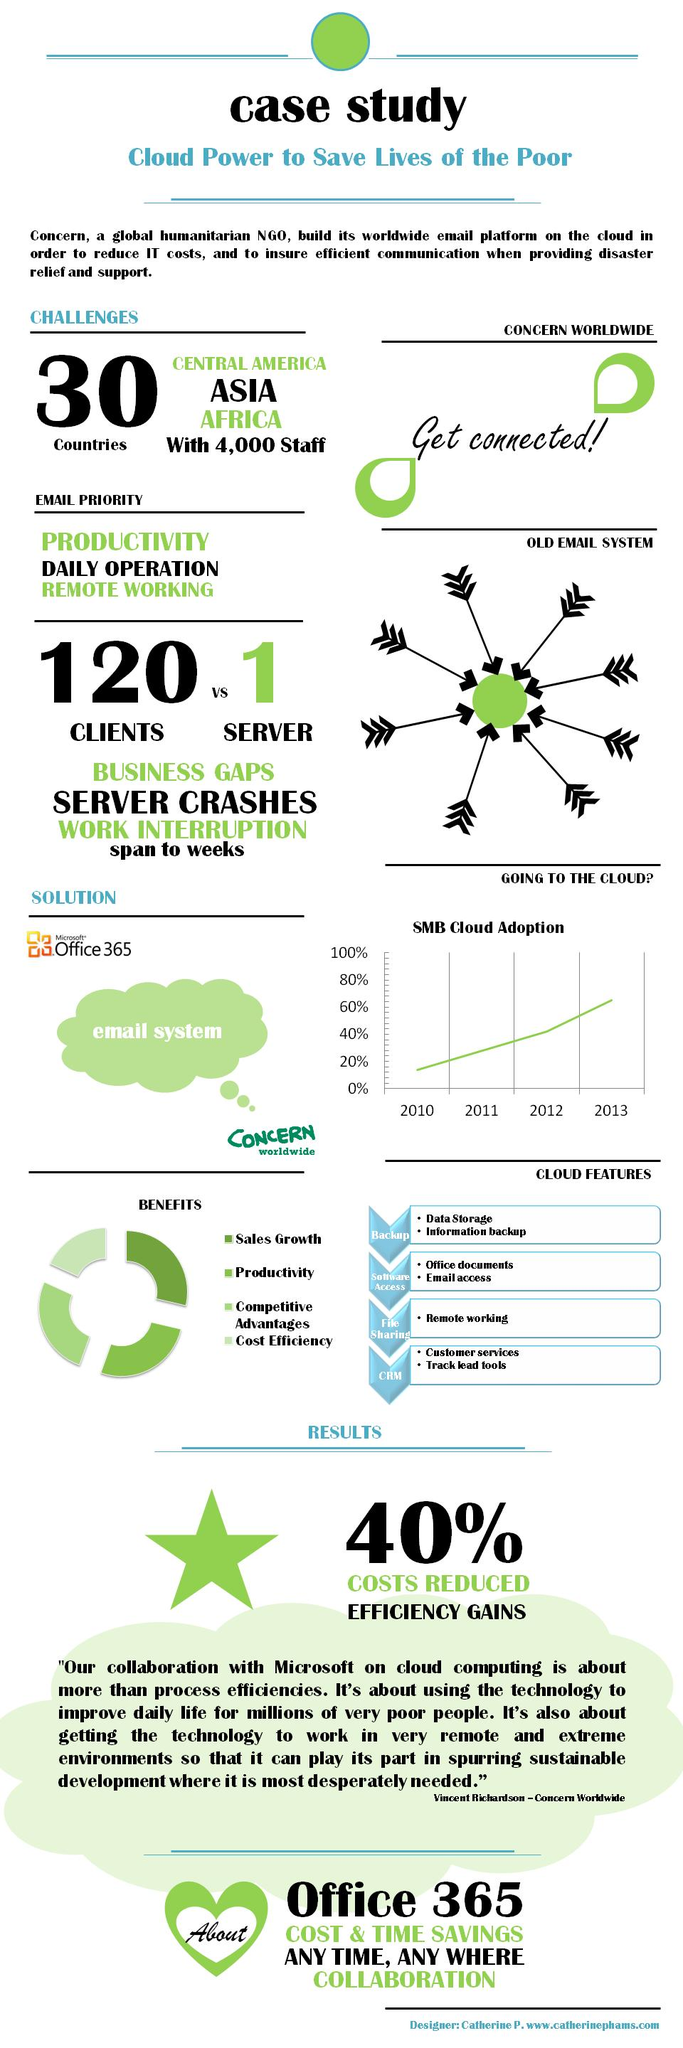Draw attention to some important aspects in this diagram. Four points are located under the heading "Cloud Features". Four points are under the heading "Benefits. 